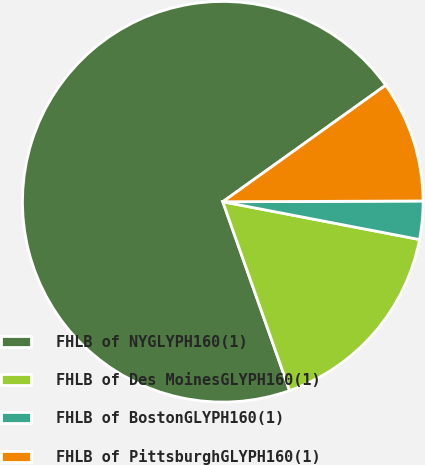Convert chart to OTSL. <chart><loc_0><loc_0><loc_500><loc_500><pie_chart><fcel>FHLB of NYGLYPH160(1)<fcel>FHLB of Des MoinesGLYPH160(1)<fcel>FHLB of BostonGLYPH160(1)<fcel>FHLB of PittsburghGLYPH160(1)<nl><fcel>70.53%<fcel>16.57%<fcel>3.08%<fcel>9.82%<nl></chart> 